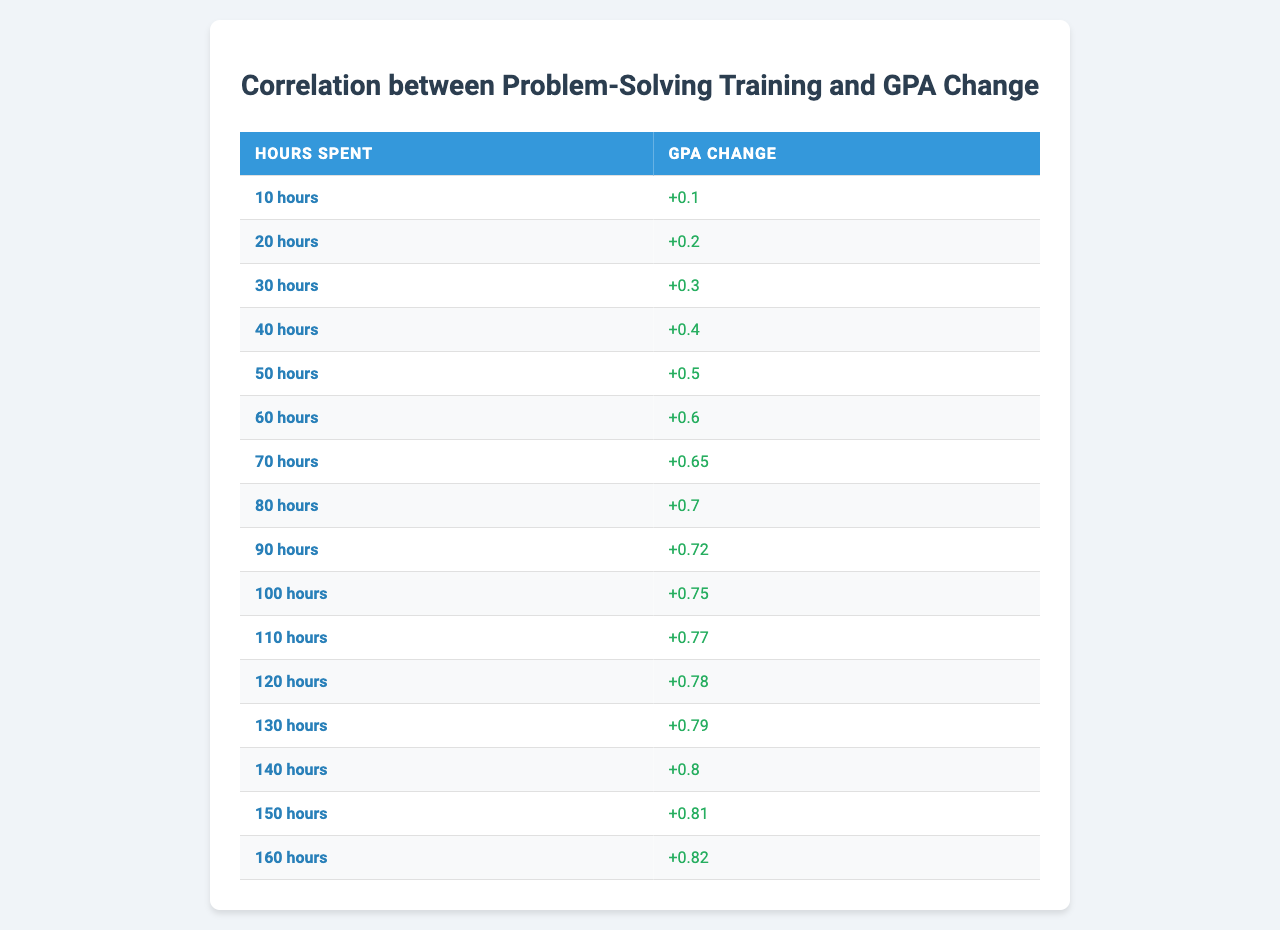What is the GPA change when 30 hours are spent? According to the table, when 30 hours are spent on problem-solving training, the GPA change is noted as 0.3
Answer: 0.3 What is the maximum GPA change observed in the table? The maximum GPA change in the table occurs when 160 hours are spent, where the change is 0.82
Answer: 0.82 How many hours correspond to a GPA change of 0.75? Looking at the table, a GPA change of 0.75 corresponds to 100 hours spent on training
Answer: 100 hours What is the difference in GPA change between spending 50 hours and 80 hours? The GPA change for 50 hours is 0.5, and for 80 hours, it is 0.7. The difference is 0.7 - 0.5 = 0.2
Answer: 0.2 Is there a point where GPA change is greater than 0.8? Yes, GPA change exceeds 0.8 when spending 140 hours (0.8), 150 hours (0.81), and 160 hours (0.82)
Answer: Yes What is the average GPA change for spending between 10 and 60 hours? The GPA changes for these hours are 0.1, 0.2, 0.3, 0.4, 0.5, 0.6. The sum is 0.1 + 0.2 + 0.3 + 0.4 + 0.5 + 0.6 = 2.1, and there are 6 data points, so the average GPA change is 2.1 / 6 = 0.35
Answer: 0.35 Which hour mark has the second highest GPA change? The hour mark just before the maximum (160 hours) is 150 hours, where the GPA change is 0.81, making it the second highest
Answer: 150 hours What is the GPA change increment from spending 10 hours to 20 hours? The GPA change increases from 0.1 at 10 hours to 0.2 at 20 hours. The increment is 0.2 - 0.1 = 0.1
Answer: 0.1 Are there any instances in the table where spending an additional 10 hours results in no increase in GPA change? No, every increase in hours spent shows a corresponding increase in GPA change
Answer: No What is the total GPA change for all hours spent from 10 to 160? Adding all GPA changes together: 0.1 + 0.2 + 0.3 + 0.4 + 0.5 + 0.6 + 0.65 + 0.7 + 0.72 + 0.75 + 0.77 + 0.78 + 0.79 + 0.8 + 0.81 + 0.82 = 11.04. Thus, the total GPA change for all reported hours is 11.04
Answer: 11.04 